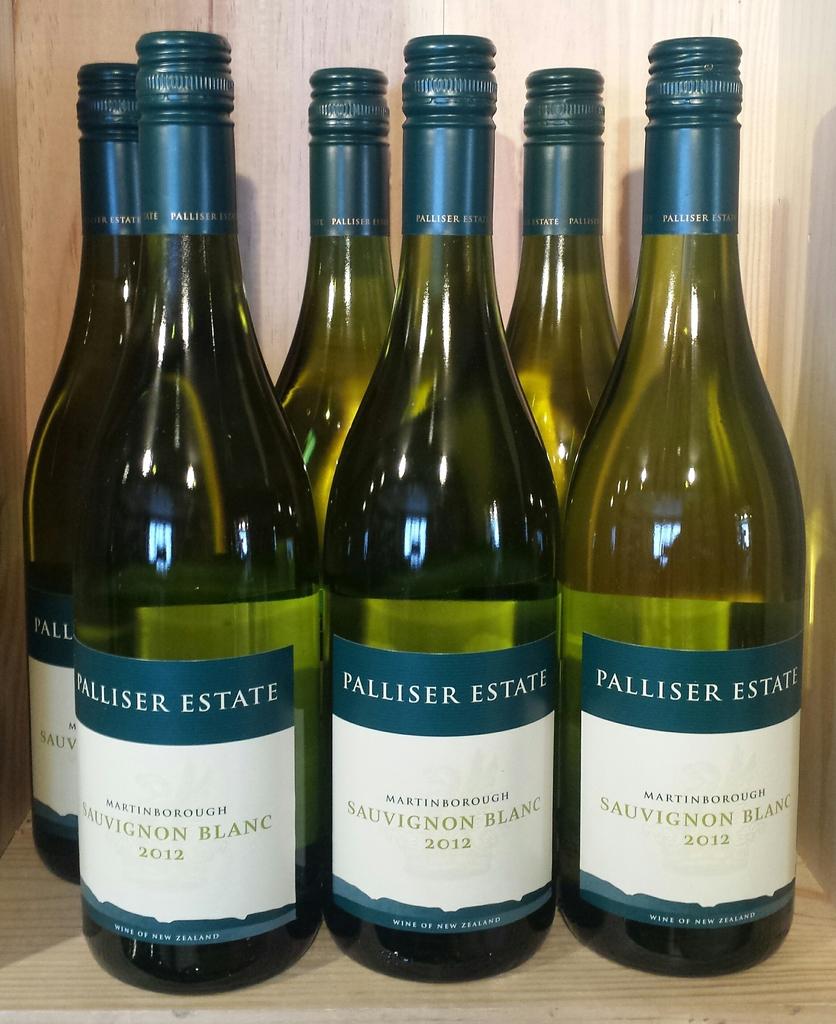What is the brand of the wine?
Provide a succinct answer. Palliser estate. 